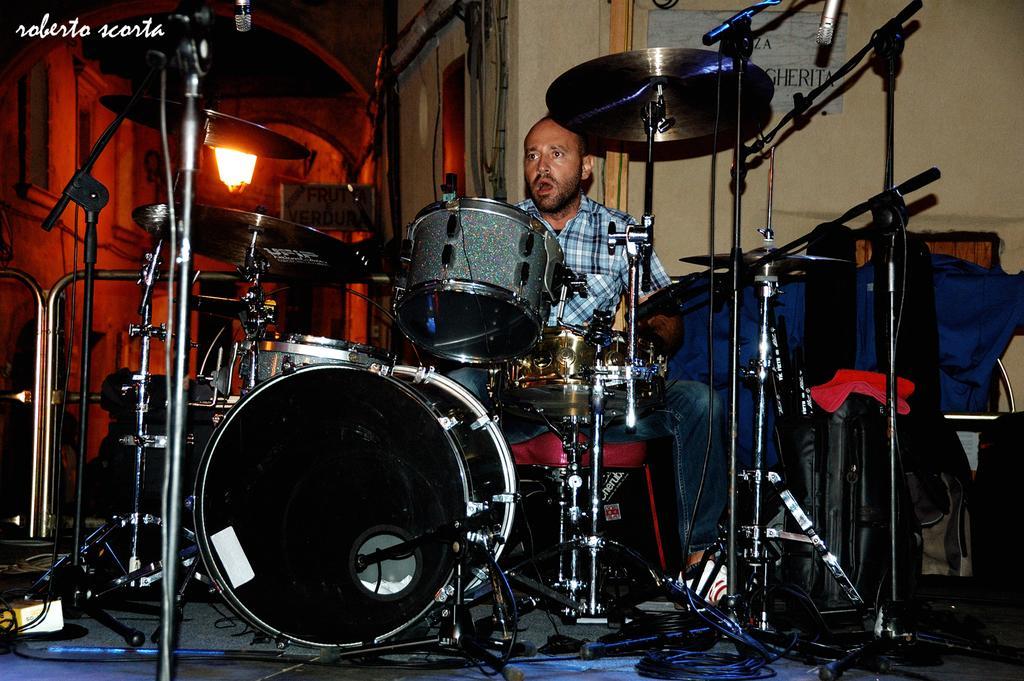Could you give a brief overview of what you see in this image? This picture is clicked inside the room. In the foreground we can see the musical instruments and the microphones which are attached to the metal stands and we can see a man wearing a shirt and sitting. In the background we can see the text on the boards which are attached to the wall and we can see the light and many other objects in the background. In the foreground we can see the cables and the metal rods. In the top right corner we can see the watermark on the image. 